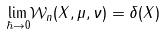<formula> <loc_0><loc_0><loc_500><loc_500>\underset { \hbar { \rightarrow } 0 } { \lim } \mathcal { W } _ { n } ( X , \mu , \nu ) = \delta ( X )</formula> 